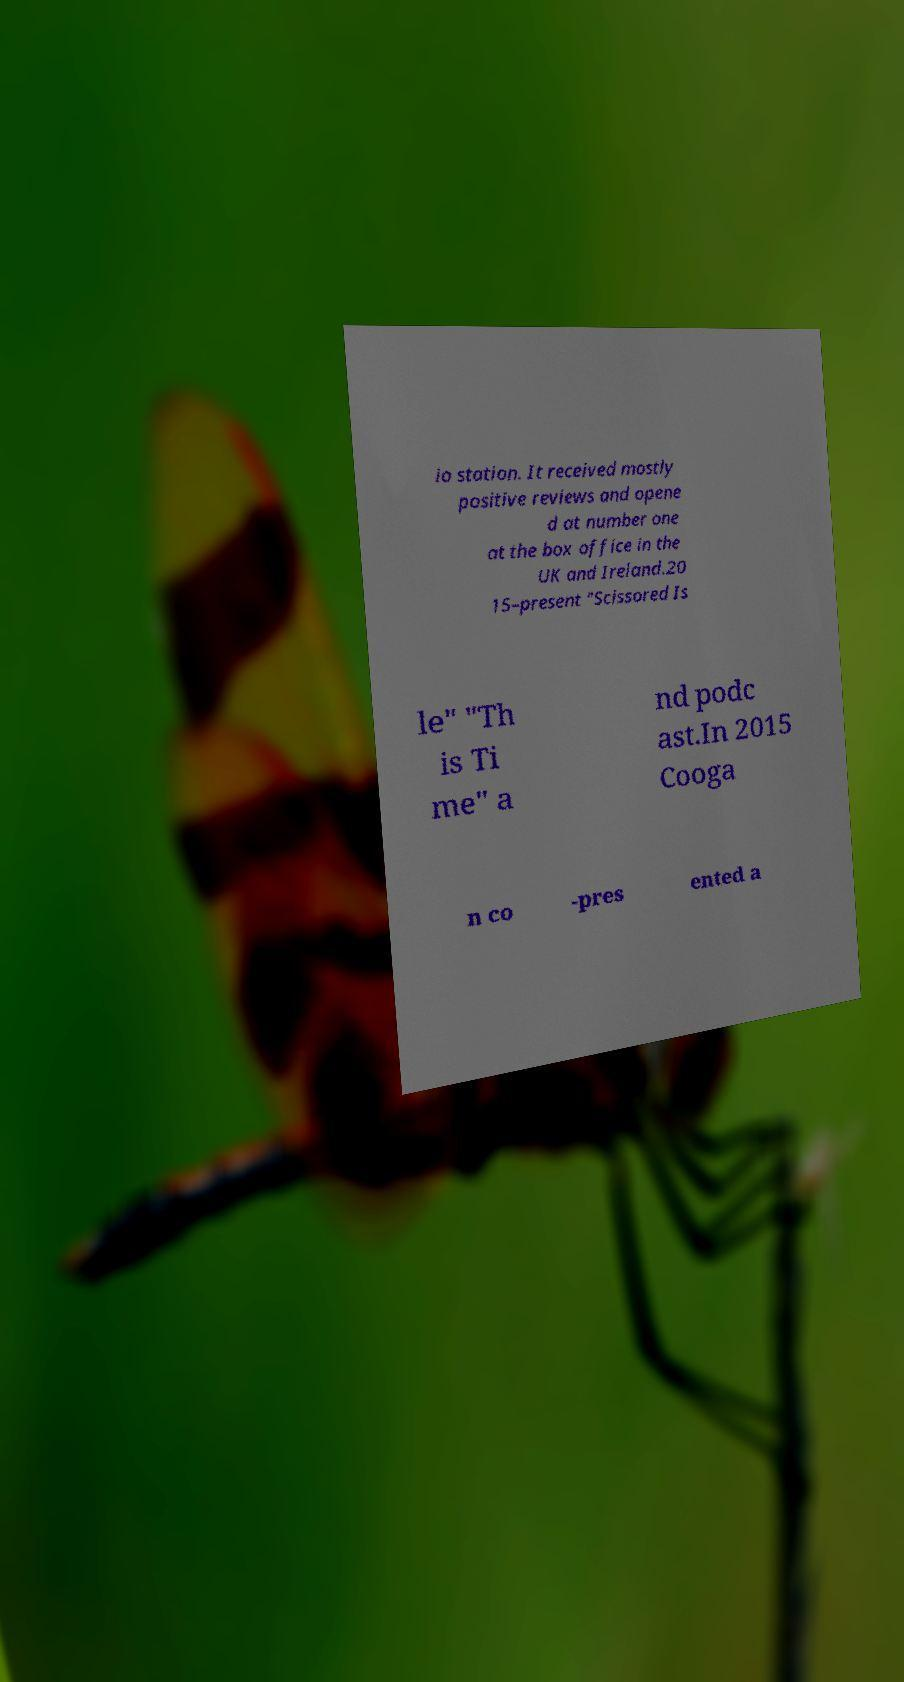For documentation purposes, I need the text within this image transcribed. Could you provide that? io station. It received mostly positive reviews and opene d at number one at the box office in the UK and Ireland.20 15–present "Scissored Is le" "Th is Ti me" a nd podc ast.In 2015 Cooga n co -pres ented a 